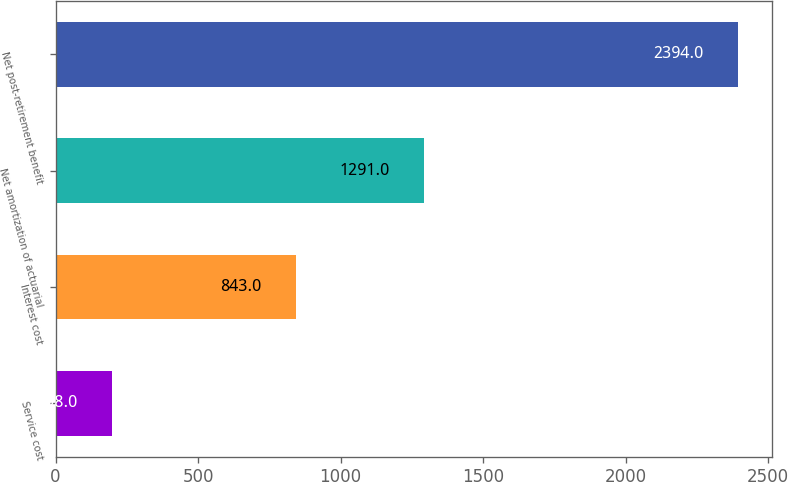Convert chart to OTSL. <chart><loc_0><loc_0><loc_500><loc_500><bar_chart><fcel>Service cost<fcel>Interest cost<fcel>Net amortization of actuarial<fcel>Net post-retirement benefit<nl><fcel>198<fcel>843<fcel>1291<fcel>2394<nl></chart> 